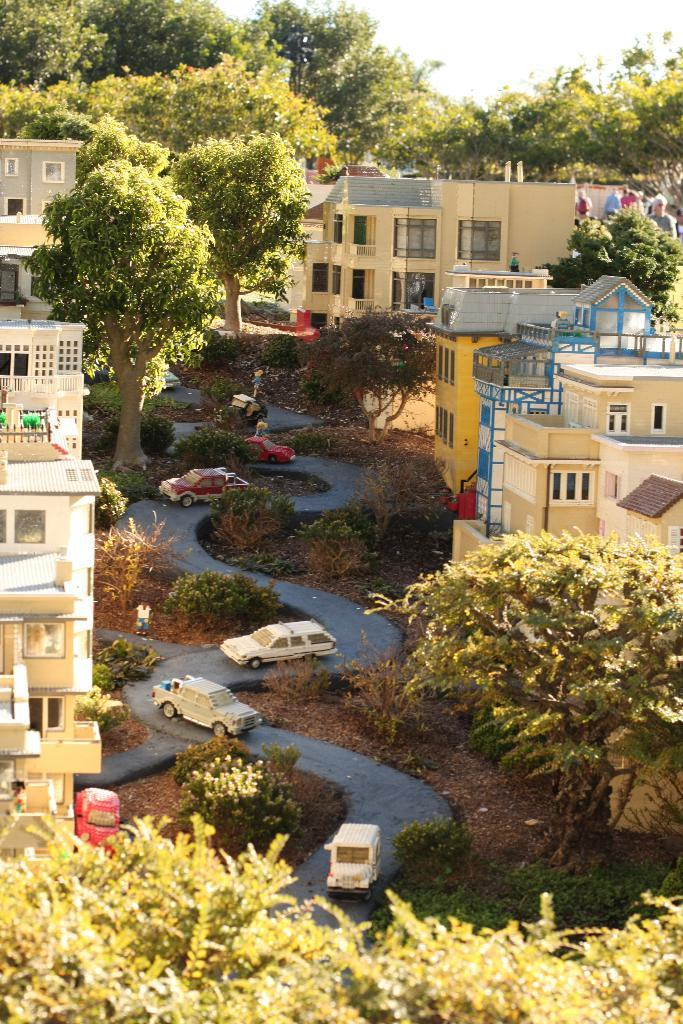What types of structures are present in the image? There are buildings in the image. What natural elements can be seen in the image? There are trees and plants in the image. What man-made objects are visible in the image? There are vehicles in the image. Are there any living beings present in the image? Yes, there are people in the image. What part of the natural environment is visible in the image? The sky is visible in the image. Where are the vehicles located in the image? The vehicles are on the road in the image. What is the profit of the daughter in the image? There is no mention of profit or a daughter in the image. Can you tell me how many beggars are present in the image? There is no mention of any beggars in the image. 